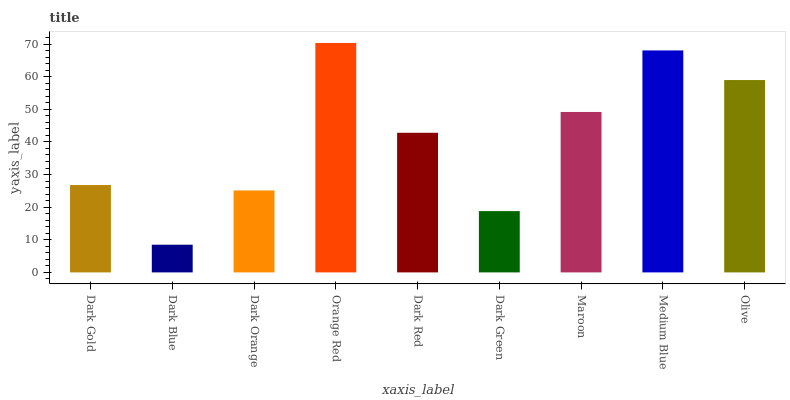Is Dark Blue the minimum?
Answer yes or no. Yes. Is Orange Red the maximum?
Answer yes or no. Yes. Is Dark Orange the minimum?
Answer yes or no. No. Is Dark Orange the maximum?
Answer yes or no. No. Is Dark Orange greater than Dark Blue?
Answer yes or no. Yes. Is Dark Blue less than Dark Orange?
Answer yes or no. Yes. Is Dark Blue greater than Dark Orange?
Answer yes or no. No. Is Dark Orange less than Dark Blue?
Answer yes or no. No. Is Dark Red the high median?
Answer yes or no. Yes. Is Dark Red the low median?
Answer yes or no. Yes. Is Dark Gold the high median?
Answer yes or no. No. Is Medium Blue the low median?
Answer yes or no. No. 